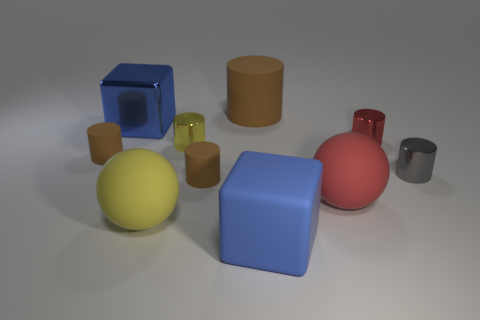Subtract all brown cylinders. How many were subtracted if there are1brown cylinders left? 2 Subtract all small brown rubber cylinders. How many cylinders are left? 4 Subtract all brown cylinders. How many cylinders are left? 3 Subtract all cylinders. How many objects are left? 4 Subtract 2 spheres. How many spheres are left? 0 Subtract all small red cylinders. Subtract all red objects. How many objects are left? 7 Add 9 large cylinders. How many large cylinders are left? 10 Add 9 metal cubes. How many metal cubes exist? 10 Subtract 1 brown cylinders. How many objects are left? 9 Subtract all gray cylinders. Subtract all green blocks. How many cylinders are left? 5 